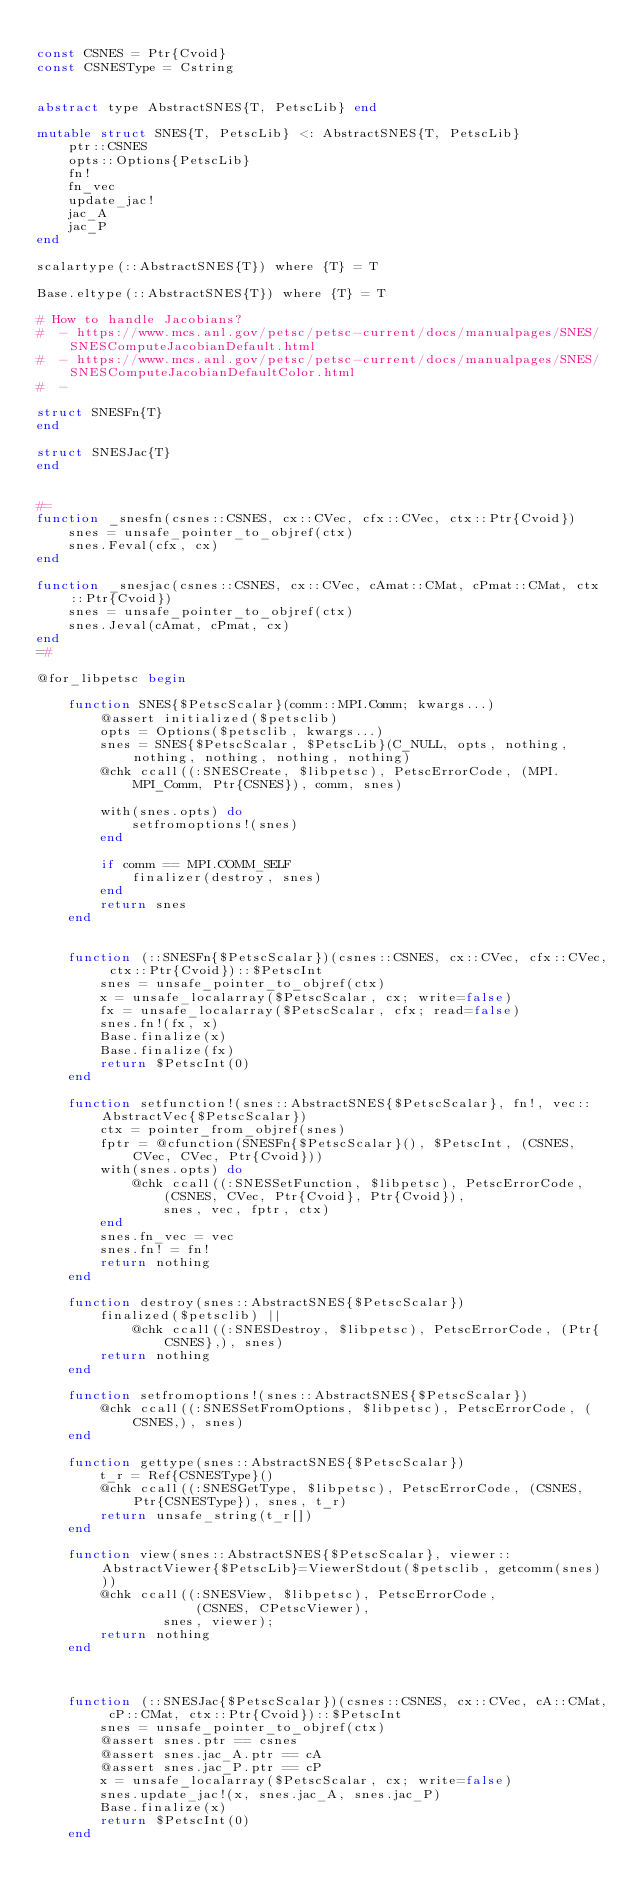Convert code to text. <code><loc_0><loc_0><loc_500><loc_500><_Julia_>
const CSNES = Ptr{Cvoid}
const CSNESType = Cstring


abstract type AbstractSNES{T, PetscLib} end

mutable struct SNES{T, PetscLib} <: AbstractSNES{T, PetscLib}
    ptr::CSNES
    opts::Options{PetscLib}
    fn!
    fn_vec
    update_jac!
    jac_A
    jac_P
end

scalartype(::AbstractSNES{T}) where {T} = T

Base.eltype(::AbstractSNES{T}) where {T} = T

# How to handle Jacobians?
#  - https://www.mcs.anl.gov/petsc/petsc-current/docs/manualpages/SNES/SNESComputeJacobianDefault.html
#  - https://www.mcs.anl.gov/petsc/petsc-current/docs/manualpages/SNES/SNESComputeJacobianDefaultColor.html
#  -

struct SNESFn{T}
end

struct SNESJac{T}
end


#=
function _snesfn(csnes::CSNES, cx::CVec, cfx::CVec, ctx::Ptr{Cvoid})
    snes = unsafe_pointer_to_objref(ctx)
    snes.Feval(cfx, cx)
end

function _snesjac(csnes::CSNES, cx::CVec, cAmat::CMat, cPmat::CMat, ctx::Ptr{Cvoid})
    snes = unsafe_pointer_to_objref(ctx)
    snes.Jeval(cAmat, cPmat, cx)
end
=#

@for_libpetsc begin

    function SNES{$PetscScalar}(comm::MPI.Comm; kwargs...)
        @assert initialized($petsclib)
        opts = Options($petsclib, kwargs...)
        snes = SNES{$PetscScalar, $PetscLib}(C_NULL, opts, nothing, nothing, nothing, nothing, nothing)
        @chk ccall((:SNESCreate, $libpetsc), PetscErrorCode, (MPI.MPI_Comm, Ptr{CSNES}), comm, snes)

        with(snes.opts) do
            setfromoptions!(snes)
        end

        if comm == MPI.COMM_SELF
            finalizer(destroy, snes)
        end
        return snes
    end


    function (::SNESFn{$PetscScalar})(csnes::CSNES, cx::CVec, cfx::CVec, ctx::Ptr{Cvoid})::$PetscInt
        snes = unsafe_pointer_to_objref(ctx)
        x = unsafe_localarray($PetscScalar, cx; write=false)
        fx = unsafe_localarray($PetscScalar, cfx; read=false)
        snes.fn!(fx, x)
        Base.finalize(x)
        Base.finalize(fx)
        return $PetscInt(0)
    end

    function setfunction!(snes::AbstractSNES{$PetscScalar}, fn!, vec::AbstractVec{$PetscScalar})
        ctx = pointer_from_objref(snes)
        fptr = @cfunction(SNESFn{$PetscScalar}(), $PetscInt, (CSNES, CVec, CVec, Ptr{Cvoid}))
        with(snes.opts) do
            @chk ccall((:SNESSetFunction, $libpetsc), PetscErrorCode,
                (CSNES, CVec, Ptr{Cvoid}, Ptr{Cvoid}),
                snes, vec, fptr, ctx)
        end
        snes.fn_vec = vec
        snes.fn! = fn!
        return nothing
    end

    function destroy(snes::AbstractSNES{$PetscScalar})
        finalized($petsclib) ||
            @chk ccall((:SNESDestroy, $libpetsc), PetscErrorCode, (Ptr{CSNES},), snes)
        return nothing
    end

    function setfromoptions!(snes::AbstractSNES{$PetscScalar})
        @chk ccall((:SNESSetFromOptions, $libpetsc), PetscErrorCode, (CSNES,), snes)
    end

    function gettype(snes::AbstractSNES{$PetscScalar})
        t_r = Ref{CSNESType}()
        @chk ccall((:SNESGetType, $libpetsc), PetscErrorCode, (CSNES, Ptr{CSNESType}), snes, t_r)
        return unsafe_string(t_r[])
    end

    function view(snes::AbstractSNES{$PetscScalar}, viewer::AbstractViewer{$PetscLib}=ViewerStdout($petsclib, getcomm(snes)))
        @chk ccall((:SNESView, $libpetsc), PetscErrorCode,
                    (CSNES, CPetscViewer),
                snes, viewer);
        return nothing
    end



    function (::SNESJac{$PetscScalar})(csnes::CSNES, cx::CVec, cA::CMat, cP::CMat, ctx::Ptr{Cvoid})::$PetscInt
        snes = unsafe_pointer_to_objref(ctx)
        @assert snes.ptr == csnes
        @assert snes.jac_A.ptr == cA
        @assert snes.jac_P.ptr == cP
        x = unsafe_localarray($PetscScalar, cx; write=false)
        snes.update_jac!(x, snes.jac_A, snes.jac_P)
        Base.finalize(x)
        return $PetscInt(0)
    end
</code> 